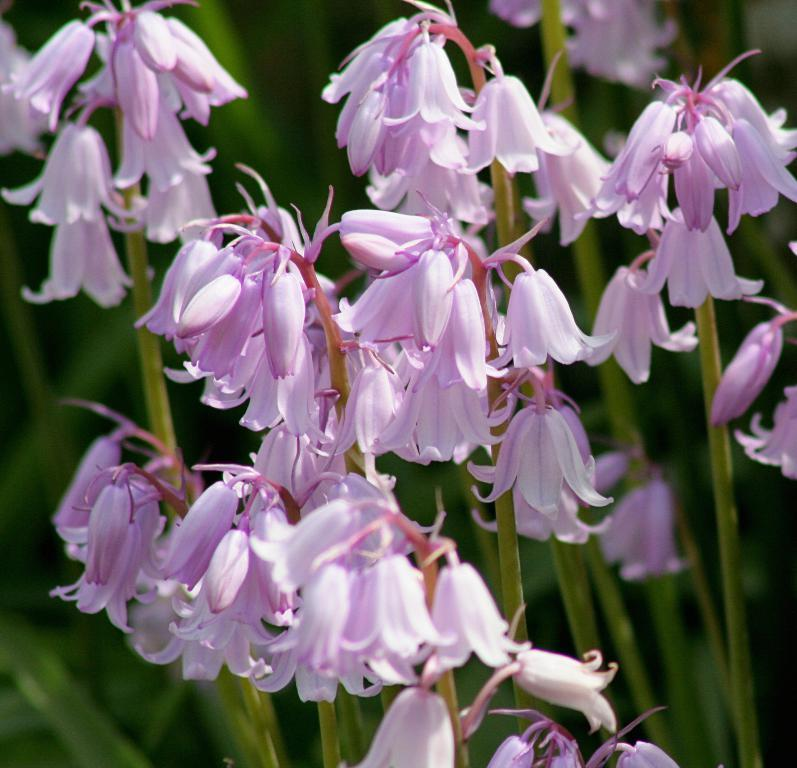What type of flowers can be seen in the image? There are pink color flowers in the image. What can be seen in the background of the image? There is greenery in the background of the image. How does the cream affect the push in the image? There is no cream or push present in the image; it only features pink color flowers and greenery in the background. 